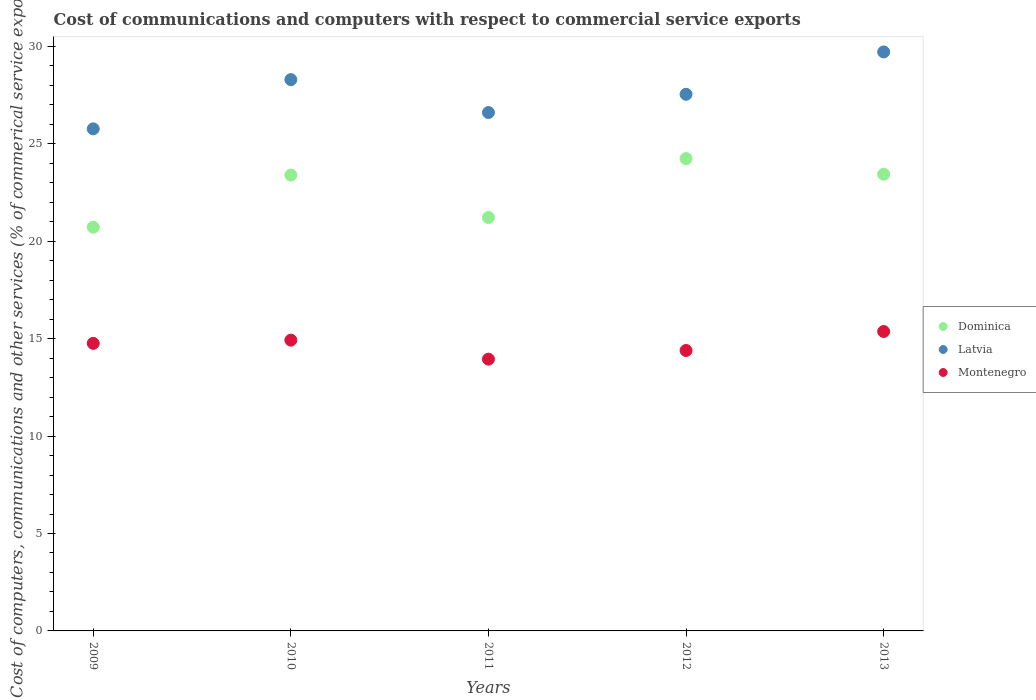How many different coloured dotlines are there?
Provide a succinct answer. 3. Is the number of dotlines equal to the number of legend labels?
Offer a very short reply. Yes. What is the cost of communications and computers in Dominica in 2011?
Make the answer very short. 21.22. Across all years, what is the maximum cost of communications and computers in Montenegro?
Give a very brief answer. 15.37. Across all years, what is the minimum cost of communications and computers in Latvia?
Give a very brief answer. 25.77. In which year was the cost of communications and computers in Montenegro maximum?
Ensure brevity in your answer.  2013. In which year was the cost of communications and computers in Montenegro minimum?
Your answer should be compact. 2011. What is the total cost of communications and computers in Dominica in the graph?
Make the answer very short. 113.01. What is the difference between the cost of communications and computers in Latvia in 2011 and that in 2012?
Keep it short and to the point. -0.94. What is the difference between the cost of communications and computers in Dominica in 2011 and the cost of communications and computers in Latvia in 2012?
Make the answer very short. -6.32. What is the average cost of communications and computers in Dominica per year?
Make the answer very short. 22.6. In the year 2011, what is the difference between the cost of communications and computers in Latvia and cost of communications and computers in Montenegro?
Offer a very short reply. 12.66. What is the ratio of the cost of communications and computers in Montenegro in 2009 to that in 2011?
Provide a short and direct response. 1.06. Is the cost of communications and computers in Dominica in 2011 less than that in 2013?
Make the answer very short. Yes. What is the difference between the highest and the second highest cost of communications and computers in Dominica?
Offer a terse response. 0.8. What is the difference between the highest and the lowest cost of communications and computers in Latvia?
Provide a short and direct response. 3.95. In how many years, is the cost of communications and computers in Latvia greater than the average cost of communications and computers in Latvia taken over all years?
Your answer should be very brief. 2. Is it the case that in every year, the sum of the cost of communications and computers in Latvia and cost of communications and computers in Montenegro  is greater than the cost of communications and computers in Dominica?
Provide a succinct answer. Yes. Is the cost of communications and computers in Latvia strictly less than the cost of communications and computers in Dominica over the years?
Ensure brevity in your answer.  No. How many dotlines are there?
Your answer should be compact. 3. Does the graph contain any zero values?
Your answer should be compact. No. Where does the legend appear in the graph?
Keep it short and to the point. Center right. How are the legend labels stacked?
Provide a succinct answer. Vertical. What is the title of the graph?
Offer a terse response. Cost of communications and computers with respect to commercial service exports. Does "Suriname" appear as one of the legend labels in the graph?
Your response must be concise. No. What is the label or title of the X-axis?
Offer a terse response. Years. What is the label or title of the Y-axis?
Keep it short and to the point. Cost of computers, communications and other services (% of commerical service exports). What is the Cost of computers, communications and other services (% of commerical service exports) in Dominica in 2009?
Keep it short and to the point. 20.72. What is the Cost of computers, communications and other services (% of commerical service exports) of Latvia in 2009?
Ensure brevity in your answer.  25.77. What is the Cost of computers, communications and other services (% of commerical service exports) in Montenegro in 2009?
Your answer should be compact. 14.76. What is the Cost of computers, communications and other services (% of commerical service exports) in Dominica in 2010?
Keep it short and to the point. 23.39. What is the Cost of computers, communications and other services (% of commerical service exports) in Latvia in 2010?
Provide a short and direct response. 28.29. What is the Cost of computers, communications and other services (% of commerical service exports) of Montenegro in 2010?
Give a very brief answer. 14.92. What is the Cost of computers, communications and other services (% of commerical service exports) in Dominica in 2011?
Offer a very short reply. 21.22. What is the Cost of computers, communications and other services (% of commerical service exports) in Latvia in 2011?
Make the answer very short. 26.6. What is the Cost of computers, communications and other services (% of commerical service exports) in Montenegro in 2011?
Your answer should be compact. 13.95. What is the Cost of computers, communications and other services (% of commerical service exports) of Dominica in 2012?
Keep it short and to the point. 24.24. What is the Cost of computers, communications and other services (% of commerical service exports) in Latvia in 2012?
Offer a terse response. 27.54. What is the Cost of computers, communications and other services (% of commerical service exports) in Montenegro in 2012?
Offer a very short reply. 14.39. What is the Cost of computers, communications and other services (% of commerical service exports) of Dominica in 2013?
Provide a succinct answer. 23.44. What is the Cost of computers, communications and other services (% of commerical service exports) of Latvia in 2013?
Your answer should be compact. 29.71. What is the Cost of computers, communications and other services (% of commerical service exports) in Montenegro in 2013?
Provide a short and direct response. 15.37. Across all years, what is the maximum Cost of computers, communications and other services (% of commerical service exports) in Dominica?
Provide a succinct answer. 24.24. Across all years, what is the maximum Cost of computers, communications and other services (% of commerical service exports) of Latvia?
Keep it short and to the point. 29.71. Across all years, what is the maximum Cost of computers, communications and other services (% of commerical service exports) in Montenegro?
Provide a succinct answer. 15.37. Across all years, what is the minimum Cost of computers, communications and other services (% of commerical service exports) of Dominica?
Your answer should be very brief. 20.72. Across all years, what is the minimum Cost of computers, communications and other services (% of commerical service exports) in Latvia?
Your response must be concise. 25.77. Across all years, what is the minimum Cost of computers, communications and other services (% of commerical service exports) of Montenegro?
Make the answer very short. 13.95. What is the total Cost of computers, communications and other services (% of commerical service exports) of Dominica in the graph?
Provide a short and direct response. 113.01. What is the total Cost of computers, communications and other services (% of commerical service exports) in Latvia in the graph?
Offer a very short reply. 137.92. What is the total Cost of computers, communications and other services (% of commerical service exports) in Montenegro in the graph?
Offer a terse response. 73.39. What is the difference between the Cost of computers, communications and other services (% of commerical service exports) of Dominica in 2009 and that in 2010?
Keep it short and to the point. -2.68. What is the difference between the Cost of computers, communications and other services (% of commerical service exports) of Latvia in 2009 and that in 2010?
Provide a short and direct response. -2.53. What is the difference between the Cost of computers, communications and other services (% of commerical service exports) in Montenegro in 2009 and that in 2010?
Make the answer very short. -0.17. What is the difference between the Cost of computers, communications and other services (% of commerical service exports) in Dominica in 2009 and that in 2011?
Your response must be concise. -0.5. What is the difference between the Cost of computers, communications and other services (% of commerical service exports) of Latvia in 2009 and that in 2011?
Offer a terse response. -0.84. What is the difference between the Cost of computers, communications and other services (% of commerical service exports) of Montenegro in 2009 and that in 2011?
Offer a very short reply. 0.81. What is the difference between the Cost of computers, communications and other services (% of commerical service exports) of Dominica in 2009 and that in 2012?
Keep it short and to the point. -3.52. What is the difference between the Cost of computers, communications and other services (% of commerical service exports) in Latvia in 2009 and that in 2012?
Your answer should be compact. -1.77. What is the difference between the Cost of computers, communications and other services (% of commerical service exports) in Montenegro in 2009 and that in 2012?
Your response must be concise. 0.37. What is the difference between the Cost of computers, communications and other services (% of commerical service exports) in Dominica in 2009 and that in 2013?
Give a very brief answer. -2.72. What is the difference between the Cost of computers, communications and other services (% of commerical service exports) in Latvia in 2009 and that in 2013?
Give a very brief answer. -3.95. What is the difference between the Cost of computers, communications and other services (% of commerical service exports) of Montenegro in 2009 and that in 2013?
Make the answer very short. -0.61. What is the difference between the Cost of computers, communications and other services (% of commerical service exports) of Dominica in 2010 and that in 2011?
Keep it short and to the point. 2.18. What is the difference between the Cost of computers, communications and other services (% of commerical service exports) of Latvia in 2010 and that in 2011?
Make the answer very short. 1.69. What is the difference between the Cost of computers, communications and other services (% of commerical service exports) in Montenegro in 2010 and that in 2011?
Ensure brevity in your answer.  0.98. What is the difference between the Cost of computers, communications and other services (% of commerical service exports) of Dominica in 2010 and that in 2012?
Ensure brevity in your answer.  -0.85. What is the difference between the Cost of computers, communications and other services (% of commerical service exports) of Latvia in 2010 and that in 2012?
Offer a very short reply. 0.75. What is the difference between the Cost of computers, communications and other services (% of commerical service exports) in Montenegro in 2010 and that in 2012?
Your answer should be compact. 0.53. What is the difference between the Cost of computers, communications and other services (% of commerical service exports) in Dominica in 2010 and that in 2013?
Keep it short and to the point. -0.04. What is the difference between the Cost of computers, communications and other services (% of commerical service exports) of Latvia in 2010 and that in 2013?
Ensure brevity in your answer.  -1.42. What is the difference between the Cost of computers, communications and other services (% of commerical service exports) of Montenegro in 2010 and that in 2013?
Your answer should be compact. -0.44. What is the difference between the Cost of computers, communications and other services (% of commerical service exports) in Dominica in 2011 and that in 2012?
Your answer should be very brief. -3.02. What is the difference between the Cost of computers, communications and other services (% of commerical service exports) in Latvia in 2011 and that in 2012?
Your response must be concise. -0.94. What is the difference between the Cost of computers, communications and other services (% of commerical service exports) in Montenegro in 2011 and that in 2012?
Offer a terse response. -0.44. What is the difference between the Cost of computers, communications and other services (% of commerical service exports) in Dominica in 2011 and that in 2013?
Keep it short and to the point. -2.22. What is the difference between the Cost of computers, communications and other services (% of commerical service exports) of Latvia in 2011 and that in 2013?
Make the answer very short. -3.11. What is the difference between the Cost of computers, communications and other services (% of commerical service exports) in Montenegro in 2011 and that in 2013?
Give a very brief answer. -1.42. What is the difference between the Cost of computers, communications and other services (% of commerical service exports) in Dominica in 2012 and that in 2013?
Offer a very short reply. 0.8. What is the difference between the Cost of computers, communications and other services (% of commerical service exports) in Latvia in 2012 and that in 2013?
Provide a short and direct response. -2.17. What is the difference between the Cost of computers, communications and other services (% of commerical service exports) in Montenegro in 2012 and that in 2013?
Ensure brevity in your answer.  -0.97. What is the difference between the Cost of computers, communications and other services (% of commerical service exports) of Dominica in 2009 and the Cost of computers, communications and other services (% of commerical service exports) of Latvia in 2010?
Provide a short and direct response. -7.57. What is the difference between the Cost of computers, communications and other services (% of commerical service exports) in Dominica in 2009 and the Cost of computers, communications and other services (% of commerical service exports) in Montenegro in 2010?
Offer a very short reply. 5.8. What is the difference between the Cost of computers, communications and other services (% of commerical service exports) in Latvia in 2009 and the Cost of computers, communications and other services (% of commerical service exports) in Montenegro in 2010?
Your response must be concise. 10.84. What is the difference between the Cost of computers, communications and other services (% of commerical service exports) of Dominica in 2009 and the Cost of computers, communications and other services (% of commerical service exports) of Latvia in 2011?
Offer a very short reply. -5.89. What is the difference between the Cost of computers, communications and other services (% of commerical service exports) of Dominica in 2009 and the Cost of computers, communications and other services (% of commerical service exports) of Montenegro in 2011?
Your answer should be compact. 6.77. What is the difference between the Cost of computers, communications and other services (% of commerical service exports) of Latvia in 2009 and the Cost of computers, communications and other services (% of commerical service exports) of Montenegro in 2011?
Make the answer very short. 11.82. What is the difference between the Cost of computers, communications and other services (% of commerical service exports) in Dominica in 2009 and the Cost of computers, communications and other services (% of commerical service exports) in Latvia in 2012?
Keep it short and to the point. -6.82. What is the difference between the Cost of computers, communications and other services (% of commerical service exports) of Dominica in 2009 and the Cost of computers, communications and other services (% of commerical service exports) of Montenegro in 2012?
Your answer should be compact. 6.33. What is the difference between the Cost of computers, communications and other services (% of commerical service exports) of Latvia in 2009 and the Cost of computers, communications and other services (% of commerical service exports) of Montenegro in 2012?
Make the answer very short. 11.37. What is the difference between the Cost of computers, communications and other services (% of commerical service exports) of Dominica in 2009 and the Cost of computers, communications and other services (% of commerical service exports) of Latvia in 2013?
Provide a succinct answer. -9. What is the difference between the Cost of computers, communications and other services (% of commerical service exports) in Dominica in 2009 and the Cost of computers, communications and other services (% of commerical service exports) in Montenegro in 2013?
Offer a very short reply. 5.35. What is the difference between the Cost of computers, communications and other services (% of commerical service exports) of Latvia in 2009 and the Cost of computers, communications and other services (% of commerical service exports) of Montenegro in 2013?
Give a very brief answer. 10.4. What is the difference between the Cost of computers, communications and other services (% of commerical service exports) of Dominica in 2010 and the Cost of computers, communications and other services (% of commerical service exports) of Latvia in 2011?
Give a very brief answer. -3.21. What is the difference between the Cost of computers, communications and other services (% of commerical service exports) in Dominica in 2010 and the Cost of computers, communications and other services (% of commerical service exports) in Montenegro in 2011?
Your response must be concise. 9.45. What is the difference between the Cost of computers, communications and other services (% of commerical service exports) of Latvia in 2010 and the Cost of computers, communications and other services (% of commerical service exports) of Montenegro in 2011?
Offer a terse response. 14.34. What is the difference between the Cost of computers, communications and other services (% of commerical service exports) of Dominica in 2010 and the Cost of computers, communications and other services (% of commerical service exports) of Latvia in 2012?
Your response must be concise. -4.15. What is the difference between the Cost of computers, communications and other services (% of commerical service exports) in Dominica in 2010 and the Cost of computers, communications and other services (% of commerical service exports) in Montenegro in 2012?
Your answer should be very brief. 9. What is the difference between the Cost of computers, communications and other services (% of commerical service exports) of Latvia in 2010 and the Cost of computers, communications and other services (% of commerical service exports) of Montenegro in 2012?
Your answer should be very brief. 13.9. What is the difference between the Cost of computers, communications and other services (% of commerical service exports) of Dominica in 2010 and the Cost of computers, communications and other services (% of commerical service exports) of Latvia in 2013?
Your answer should be compact. -6.32. What is the difference between the Cost of computers, communications and other services (% of commerical service exports) of Dominica in 2010 and the Cost of computers, communications and other services (% of commerical service exports) of Montenegro in 2013?
Ensure brevity in your answer.  8.03. What is the difference between the Cost of computers, communications and other services (% of commerical service exports) in Latvia in 2010 and the Cost of computers, communications and other services (% of commerical service exports) in Montenegro in 2013?
Your answer should be very brief. 12.93. What is the difference between the Cost of computers, communications and other services (% of commerical service exports) in Dominica in 2011 and the Cost of computers, communications and other services (% of commerical service exports) in Latvia in 2012?
Offer a very short reply. -6.32. What is the difference between the Cost of computers, communications and other services (% of commerical service exports) of Dominica in 2011 and the Cost of computers, communications and other services (% of commerical service exports) of Montenegro in 2012?
Provide a short and direct response. 6.83. What is the difference between the Cost of computers, communications and other services (% of commerical service exports) in Latvia in 2011 and the Cost of computers, communications and other services (% of commerical service exports) in Montenegro in 2012?
Give a very brief answer. 12.21. What is the difference between the Cost of computers, communications and other services (% of commerical service exports) in Dominica in 2011 and the Cost of computers, communications and other services (% of commerical service exports) in Latvia in 2013?
Make the answer very short. -8.49. What is the difference between the Cost of computers, communications and other services (% of commerical service exports) of Dominica in 2011 and the Cost of computers, communications and other services (% of commerical service exports) of Montenegro in 2013?
Give a very brief answer. 5.85. What is the difference between the Cost of computers, communications and other services (% of commerical service exports) in Latvia in 2011 and the Cost of computers, communications and other services (% of commerical service exports) in Montenegro in 2013?
Provide a short and direct response. 11.24. What is the difference between the Cost of computers, communications and other services (% of commerical service exports) of Dominica in 2012 and the Cost of computers, communications and other services (% of commerical service exports) of Latvia in 2013?
Offer a very short reply. -5.47. What is the difference between the Cost of computers, communications and other services (% of commerical service exports) of Dominica in 2012 and the Cost of computers, communications and other services (% of commerical service exports) of Montenegro in 2013?
Your answer should be very brief. 8.87. What is the difference between the Cost of computers, communications and other services (% of commerical service exports) in Latvia in 2012 and the Cost of computers, communications and other services (% of commerical service exports) in Montenegro in 2013?
Make the answer very short. 12.17. What is the average Cost of computers, communications and other services (% of commerical service exports) of Dominica per year?
Provide a short and direct response. 22.6. What is the average Cost of computers, communications and other services (% of commerical service exports) in Latvia per year?
Your answer should be compact. 27.58. What is the average Cost of computers, communications and other services (% of commerical service exports) of Montenegro per year?
Give a very brief answer. 14.68. In the year 2009, what is the difference between the Cost of computers, communications and other services (% of commerical service exports) of Dominica and Cost of computers, communications and other services (% of commerical service exports) of Latvia?
Keep it short and to the point. -5.05. In the year 2009, what is the difference between the Cost of computers, communications and other services (% of commerical service exports) of Dominica and Cost of computers, communications and other services (% of commerical service exports) of Montenegro?
Provide a succinct answer. 5.96. In the year 2009, what is the difference between the Cost of computers, communications and other services (% of commerical service exports) of Latvia and Cost of computers, communications and other services (% of commerical service exports) of Montenegro?
Give a very brief answer. 11.01. In the year 2010, what is the difference between the Cost of computers, communications and other services (% of commerical service exports) in Dominica and Cost of computers, communications and other services (% of commerical service exports) in Latvia?
Your answer should be very brief. -4.9. In the year 2010, what is the difference between the Cost of computers, communications and other services (% of commerical service exports) in Dominica and Cost of computers, communications and other services (% of commerical service exports) in Montenegro?
Offer a very short reply. 8.47. In the year 2010, what is the difference between the Cost of computers, communications and other services (% of commerical service exports) in Latvia and Cost of computers, communications and other services (% of commerical service exports) in Montenegro?
Keep it short and to the point. 13.37. In the year 2011, what is the difference between the Cost of computers, communications and other services (% of commerical service exports) of Dominica and Cost of computers, communications and other services (% of commerical service exports) of Latvia?
Ensure brevity in your answer.  -5.39. In the year 2011, what is the difference between the Cost of computers, communications and other services (% of commerical service exports) of Dominica and Cost of computers, communications and other services (% of commerical service exports) of Montenegro?
Provide a short and direct response. 7.27. In the year 2011, what is the difference between the Cost of computers, communications and other services (% of commerical service exports) in Latvia and Cost of computers, communications and other services (% of commerical service exports) in Montenegro?
Ensure brevity in your answer.  12.66. In the year 2012, what is the difference between the Cost of computers, communications and other services (% of commerical service exports) of Dominica and Cost of computers, communications and other services (% of commerical service exports) of Latvia?
Provide a succinct answer. -3.3. In the year 2012, what is the difference between the Cost of computers, communications and other services (% of commerical service exports) in Dominica and Cost of computers, communications and other services (% of commerical service exports) in Montenegro?
Give a very brief answer. 9.85. In the year 2012, what is the difference between the Cost of computers, communications and other services (% of commerical service exports) of Latvia and Cost of computers, communications and other services (% of commerical service exports) of Montenegro?
Your answer should be compact. 13.15. In the year 2013, what is the difference between the Cost of computers, communications and other services (% of commerical service exports) in Dominica and Cost of computers, communications and other services (% of commerical service exports) in Latvia?
Make the answer very short. -6.28. In the year 2013, what is the difference between the Cost of computers, communications and other services (% of commerical service exports) in Dominica and Cost of computers, communications and other services (% of commerical service exports) in Montenegro?
Your answer should be compact. 8.07. In the year 2013, what is the difference between the Cost of computers, communications and other services (% of commerical service exports) in Latvia and Cost of computers, communications and other services (% of commerical service exports) in Montenegro?
Make the answer very short. 14.35. What is the ratio of the Cost of computers, communications and other services (% of commerical service exports) in Dominica in 2009 to that in 2010?
Provide a succinct answer. 0.89. What is the ratio of the Cost of computers, communications and other services (% of commerical service exports) of Latvia in 2009 to that in 2010?
Your response must be concise. 0.91. What is the ratio of the Cost of computers, communications and other services (% of commerical service exports) of Montenegro in 2009 to that in 2010?
Your response must be concise. 0.99. What is the ratio of the Cost of computers, communications and other services (% of commerical service exports) in Dominica in 2009 to that in 2011?
Give a very brief answer. 0.98. What is the ratio of the Cost of computers, communications and other services (% of commerical service exports) of Latvia in 2009 to that in 2011?
Give a very brief answer. 0.97. What is the ratio of the Cost of computers, communications and other services (% of commerical service exports) in Montenegro in 2009 to that in 2011?
Offer a very short reply. 1.06. What is the ratio of the Cost of computers, communications and other services (% of commerical service exports) of Dominica in 2009 to that in 2012?
Your response must be concise. 0.85. What is the ratio of the Cost of computers, communications and other services (% of commerical service exports) in Latvia in 2009 to that in 2012?
Make the answer very short. 0.94. What is the ratio of the Cost of computers, communications and other services (% of commerical service exports) of Montenegro in 2009 to that in 2012?
Offer a very short reply. 1.03. What is the ratio of the Cost of computers, communications and other services (% of commerical service exports) in Dominica in 2009 to that in 2013?
Give a very brief answer. 0.88. What is the ratio of the Cost of computers, communications and other services (% of commerical service exports) in Latvia in 2009 to that in 2013?
Keep it short and to the point. 0.87. What is the ratio of the Cost of computers, communications and other services (% of commerical service exports) of Montenegro in 2009 to that in 2013?
Make the answer very short. 0.96. What is the ratio of the Cost of computers, communications and other services (% of commerical service exports) in Dominica in 2010 to that in 2011?
Make the answer very short. 1.1. What is the ratio of the Cost of computers, communications and other services (% of commerical service exports) in Latvia in 2010 to that in 2011?
Offer a very short reply. 1.06. What is the ratio of the Cost of computers, communications and other services (% of commerical service exports) in Montenegro in 2010 to that in 2011?
Offer a very short reply. 1.07. What is the ratio of the Cost of computers, communications and other services (% of commerical service exports) in Dominica in 2010 to that in 2012?
Offer a very short reply. 0.97. What is the ratio of the Cost of computers, communications and other services (% of commerical service exports) of Latvia in 2010 to that in 2012?
Provide a short and direct response. 1.03. What is the ratio of the Cost of computers, communications and other services (% of commerical service exports) of Montenegro in 2010 to that in 2012?
Make the answer very short. 1.04. What is the ratio of the Cost of computers, communications and other services (% of commerical service exports) in Latvia in 2010 to that in 2013?
Offer a terse response. 0.95. What is the ratio of the Cost of computers, communications and other services (% of commerical service exports) of Montenegro in 2010 to that in 2013?
Give a very brief answer. 0.97. What is the ratio of the Cost of computers, communications and other services (% of commerical service exports) of Dominica in 2011 to that in 2012?
Your answer should be compact. 0.88. What is the ratio of the Cost of computers, communications and other services (% of commerical service exports) of Montenegro in 2011 to that in 2012?
Your answer should be very brief. 0.97. What is the ratio of the Cost of computers, communications and other services (% of commerical service exports) of Dominica in 2011 to that in 2013?
Provide a short and direct response. 0.91. What is the ratio of the Cost of computers, communications and other services (% of commerical service exports) of Latvia in 2011 to that in 2013?
Make the answer very short. 0.9. What is the ratio of the Cost of computers, communications and other services (% of commerical service exports) in Montenegro in 2011 to that in 2013?
Your answer should be compact. 0.91. What is the ratio of the Cost of computers, communications and other services (% of commerical service exports) of Dominica in 2012 to that in 2013?
Ensure brevity in your answer.  1.03. What is the ratio of the Cost of computers, communications and other services (% of commerical service exports) in Latvia in 2012 to that in 2013?
Offer a terse response. 0.93. What is the ratio of the Cost of computers, communications and other services (% of commerical service exports) of Montenegro in 2012 to that in 2013?
Offer a terse response. 0.94. What is the difference between the highest and the second highest Cost of computers, communications and other services (% of commerical service exports) in Dominica?
Your answer should be compact. 0.8. What is the difference between the highest and the second highest Cost of computers, communications and other services (% of commerical service exports) of Latvia?
Ensure brevity in your answer.  1.42. What is the difference between the highest and the second highest Cost of computers, communications and other services (% of commerical service exports) of Montenegro?
Ensure brevity in your answer.  0.44. What is the difference between the highest and the lowest Cost of computers, communications and other services (% of commerical service exports) of Dominica?
Make the answer very short. 3.52. What is the difference between the highest and the lowest Cost of computers, communications and other services (% of commerical service exports) of Latvia?
Ensure brevity in your answer.  3.95. What is the difference between the highest and the lowest Cost of computers, communications and other services (% of commerical service exports) in Montenegro?
Offer a very short reply. 1.42. 